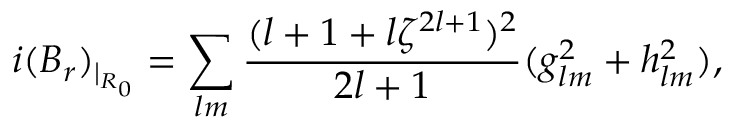Convert formula to latex. <formula><loc_0><loc_0><loc_500><loc_500>i ( B _ { r } ) _ { | _ { R _ { 0 } } } = \sum _ { l m } \frac { ( l + 1 + l \zeta ^ { 2 l + 1 } ) ^ { 2 } } { 2 l + 1 } ( g _ { l m } ^ { 2 } + h _ { l m } ^ { 2 } ) ,</formula> 